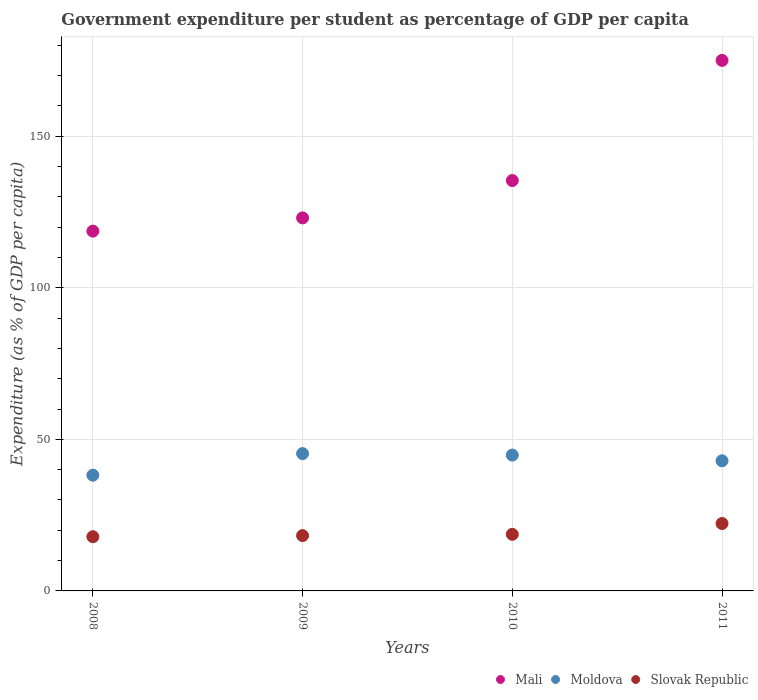What is the percentage of expenditure per student in Moldova in 2008?
Make the answer very short. 38.18. Across all years, what is the maximum percentage of expenditure per student in Moldova?
Your answer should be compact. 45.31. Across all years, what is the minimum percentage of expenditure per student in Mali?
Ensure brevity in your answer.  118.71. In which year was the percentage of expenditure per student in Mali maximum?
Provide a short and direct response. 2011. In which year was the percentage of expenditure per student in Mali minimum?
Your answer should be compact. 2008. What is the total percentage of expenditure per student in Slovak Republic in the graph?
Your answer should be compact. 77.05. What is the difference between the percentage of expenditure per student in Mali in 2008 and that in 2011?
Make the answer very short. -56.33. What is the difference between the percentage of expenditure per student in Slovak Republic in 2010 and the percentage of expenditure per student in Mali in 2008?
Ensure brevity in your answer.  -100.04. What is the average percentage of expenditure per student in Mali per year?
Provide a succinct answer. 138.06. In the year 2008, what is the difference between the percentage of expenditure per student in Slovak Republic and percentage of expenditure per student in Mali?
Make the answer very short. -100.82. In how many years, is the percentage of expenditure per student in Moldova greater than 170 %?
Provide a short and direct response. 0. What is the ratio of the percentage of expenditure per student in Slovak Republic in 2008 to that in 2011?
Provide a succinct answer. 0.8. Is the percentage of expenditure per student in Moldova in 2008 less than that in 2009?
Offer a very short reply. Yes. Is the difference between the percentage of expenditure per student in Slovak Republic in 2009 and 2010 greater than the difference between the percentage of expenditure per student in Mali in 2009 and 2010?
Ensure brevity in your answer.  Yes. What is the difference between the highest and the second highest percentage of expenditure per student in Slovak Republic?
Your answer should be very brief. 3.56. What is the difference between the highest and the lowest percentage of expenditure per student in Mali?
Offer a terse response. 56.33. In how many years, is the percentage of expenditure per student in Slovak Republic greater than the average percentage of expenditure per student in Slovak Republic taken over all years?
Your response must be concise. 1. Does the percentage of expenditure per student in Slovak Republic monotonically increase over the years?
Your answer should be compact. Yes. Is the percentage of expenditure per student in Moldova strictly less than the percentage of expenditure per student in Mali over the years?
Your answer should be very brief. Yes. How many dotlines are there?
Offer a very short reply. 3. What is the difference between two consecutive major ticks on the Y-axis?
Your answer should be compact. 50. Are the values on the major ticks of Y-axis written in scientific E-notation?
Provide a succinct answer. No. Does the graph contain grids?
Provide a short and direct response. Yes. Where does the legend appear in the graph?
Provide a short and direct response. Bottom right. How are the legend labels stacked?
Your response must be concise. Horizontal. What is the title of the graph?
Offer a very short reply. Government expenditure per student as percentage of GDP per capita. What is the label or title of the Y-axis?
Ensure brevity in your answer.  Expenditure (as % of GDP per capita). What is the Expenditure (as % of GDP per capita) of Mali in 2008?
Make the answer very short. 118.71. What is the Expenditure (as % of GDP per capita) of Moldova in 2008?
Provide a short and direct response. 38.18. What is the Expenditure (as % of GDP per capita) in Slovak Republic in 2008?
Keep it short and to the point. 17.89. What is the Expenditure (as % of GDP per capita) in Mali in 2009?
Your answer should be compact. 123.07. What is the Expenditure (as % of GDP per capita) in Moldova in 2009?
Offer a very short reply. 45.31. What is the Expenditure (as % of GDP per capita) of Slovak Republic in 2009?
Provide a succinct answer. 18.25. What is the Expenditure (as % of GDP per capita) of Mali in 2010?
Your answer should be very brief. 135.4. What is the Expenditure (as % of GDP per capita) of Moldova in 2010?
Your response must be concise. 44.82. What is the Expenditure (as % of GDP per capita) in Slovak Republic in 2010?
Offer a terse response. 18.67. What is the Expenditure (as % of GDP per capita) of Mali in 2011?
Keep it short and to the point. 175.04. What is the Expenditure (as % of GDP per capita) in Moldova in 2011?
Your response must be concise. 42.94. What is the Expenditure (as % of GDP per capita) in Slovak Republic in 2011?
Offer a terse response. 22.24. Across all years, what is the maximum Expenditure (as % of GDP per capita) in Mali?
Your response must be concise. 175.04. Across all years, what is the maximum Expenditure (as % of GDP per capita) of Moldova?
Your answer should be very brief. 45.31. Across all years, what is the maximum Expenditure (as % of GDP per capita) in Slovak Republic?
Give a very brief answer. 22.24. Across all years, what is the minimum Expenditure (as % of GDP per capita) in Mali?
Offer a terse response. 118.71. Across all years, what is the minimum Expenditure (as % of GDP per capita) in Moldova?
Your response must be concise. 38.18. Across all years, what is the minimum Expenditure (as % of GDP per capita) of Slovak Republic?
Offer a very short reply. 17.89. What is the total Expenditure (as % of GDP per capita) of Mali in the graph?
Your response must be concise. 552.23. What is the total Expenditure (as % of GDP per capita) of Moldova in the graph?
Provide a succinct answer. 171.25. What is the total Expenditure (as % of GDP per capita) in Slovak Republic in the graph?
Make the answer very short. 77.05. What is the difference between the Expenditure (as % of GDP per capita) in Mali in 2008 and that in 2009?
Your answer should be very brief. -4.36. What is the difference between the Expenditure (as % of GDP per capita) in Moldova in 2008 and that in 2009?
Ensure brevity in your answer.  -7.12. What is the difference between the Expenditure (as % of GDP per capita) of Slovak Republic in 2008 and that in 2009?
Provide a short and direct response. -0.36. What is the difference between the Expenditure (as % of GDP per capita) in Mali in 2008 and that in 2010?
Provide a short and direct response. -16.69. What is the difference between the Expenditure (as % of GDP per capita) in Moldova in 2008 and that in 2010?
Provide a succinct answer. -6.64. What is the difference between the Expenditure (as % of GDP per capita) in Slovak Republic in 2008 and that in 2010?
Your response must be concise. -0.79. What is the difference between the Expenditure (as % of GDP per capita) in Mali in 2008 and that in 2011?
Make the answer very short. -56.33. What is the difference between the Expenditure (as % of GDP per capita) in Moldova in 2008 and that in 2011?
Your response must be concise. -4.75. What is the difference between the Expenditure (as % of GDP per capita) of Slovak Republic in 2008 and that in 2011?
Offer a very short reply. -4.35. What is the difference between the Expenditure (as % of GDP per capita) of Mali in 2009 and that in 2010?
Your answer should be very brief. -12.33. What is the difference between the Expenditure (as % of GDP per capita) in Moldova in 2009 and that in 2010?
Offer a terse response. 0.48. What is the difference between the Expenditure (as % of GDP per capita) of Slovak Republic in 2009 and that in 2010?
Your answer should be compact. -0.42. What is the difference between the Expenditure (as % of GDP per capita) in Mali in 2009 and that in 2011?
Make the answer very short. -51.97. What is the difference between the Expenditure (as % of GDP per capita) of Moldova in 2009 and that in 2011?
Your response must be concise. 2.37. What is the difference between the Expenditure (as % of GDP per capita) of Slovak Republic in 2009 and that in 2011?
Your answer should be very brief. -3.99. What is the difference between the Expenditure (as % of GDP per capita) in Mali in 2010 and that in 2011?
Ensure brevity in your answer.  -39.64. What is the difference between the Expenditure (as % of GDP per capita) of Moldova in 2010 and that in 2011?
Give a very brief answer. 1.89. What is the difference between the Expenditure (as % of GDP per capita) of Slovak Republic in 2010 and that in 2011?
Provide a short and direct response. -3.56. What is the difference between the Expenditure (as % of GDP per capita) in Mali in 2008 and the Expenditure (as % of GDP per capita) in Moldova in 2009?
Ensure brevity in your answer.  73.4. What is the difference between the Expenditure (as % of GDP per capita) of Mali in 2008 and the Expenditure (as % of GDP per capita) of Slovak Republic in 2009?
Offer a very short reply. 100.46. What is the difference between the Expenditure (as % of GDP per capita) in Moldova in 2008 and the Expenditure (as % of GDP per capita) in Slovak Republic in 2009?
Your answer should be compact. 19.93. What is the difference between the Expenditure (as % of GDP per capita) in Mali in 2008 and the Expenditure (as % of GDP per capita) in Moldova in 2010?
Give a very brief answer. 73.89. What is the difference between the Expenditure (as % of GDP per capita) in Mali in 2008 and the Expenditure (as % of GDP per capita) in Slovak Republic in 2010?
Make the answer very short. 100.04. What is the difference between the Expenditure (as % of GDP per capita) in Moldova in 2008 and the Expenditure (as % of GDP per capita) in Slovak Republic in 2010?
Keep it short and to the point. 19.51. What is the difference between the Expenditure (as % of GDP per capita) in Mali in 2008 and the Expenditure (as % of GDP per capita) in Moldova in 2011?
Keep it short and to the point. 75.78. What is the difference between the Expenditure (as % of GDP per capita) in Mali in 2008 and the Expenditure (as % of GDP per capita) in Slovak Republic in 2011?
Offer a very short reply. 96.47. What is the difference between the Expenditure (as % of GDP per capita) in Moldova in 2008 and the Expenditure (as % of GDP per capita) in Slovak Republic in 2011?
Your answer should be very brief. 15.95. What is the difference between the Expenditure (as % of GDP per capita) of Mali in 2009 and the Expenditure (as % of GDP per capita) of Moldova in 2010?
Your answer should be very brief. 78.25. What is the difference between the Expenditure (as % of GDP per capita) of Mali in 2009 and the Expenditure (as % of GDP per capita) of Slovak Republic in 2010?
Make the answer very short. 104.4. What is the difference between the Expenditure (as % of GDP per capita) of Moldova in 2009 and the Expenditure (as % of GDP per capita) of Slovak Republic in 2010?
Give a very brief answer. 26.64. What is the difference between the Expenditure (as % of GDP per capita) of Mali in 2009 and the Expenditure (as % of GDP per capita) of Moldova in 2011?
Provide a short and direct response. 80.14. What is the difference between the Expenditure (as % of GDP per capita) in Mali in 2009 and the Expenditure (as % of GDP per capita) in Slovak Republic in 2011?
Provide a short and direct response. 100.84. What is the difference between the Expenditure (as % of GDP per capita) in Moldova in 2009 and the Expenditure (as % of GDP per capita) in Slovak Republic in 2011?
Your response must be concise. 23.07. What is the difference between the Expenditure (as % of GDP per capita) in Mali in 2010 and the Expenditure (as % of GDP per capita) in Moldova in 2011?
Provide a short and direct response. 92.47. What is the difference between the Expenditure (as % of GDP per capita) of Mali in 2010 and the Expenditure (as % of GDP per capita) of Slovak Republic in 2011?
Provide a succinct answer. 113.17. What is the difference between the Expenditure (as % of GDP per capita) in Moldova in 2010 and the Expenditure (as % of GDP per capita) in Slovak Republic in 2011?
Provide a succinct answer. 22.59. What is the average Expenditure (as % of GDP per capita) in Mali per year?
Give a very brief answer. 138.06. What is the average Expenditure (as % of GDP per capita) in Moldova per year?
Give a very brief answer. 42.81. What is the average Expenditure (as % of GDP per capita) in Slovak Republic per year?
Your answer should be compact. 19.26. In the year 2008, what is the difference between the Expenditure (as % of GDP per capita) in Mali and Expenditure (as % of GDP per capita) in Moldova?
Your answer should be very brief. 80.53. In the year 2008, what is the difference between the Expenditure (as % of GDP per capita) of Mali and Expenditure (as % of GDP per capita) of Slovak Republic?
Your response must be concise. 100.82. In the year 2008, what is the difference between the Expenditure (as % of GDP per capita) in Moldova and Expenditure (as % of GDP per capita) in Slovak Republic?
Give a very brief answer. 20.3. In the year 2009, what is the difference between the Expenditure (as % of GDP per capita) of Mali and Expenditure (as % of GDP per capita) of Moldova?
Provide a short and direct response. 77.76. In the year 2009, what is the difference between the Expenditure (as % of GDP per capita) of Mali and Expenditure (as % of GDP per capita) of Slovak Republic?
Your answer should be compact. 104.82. In the year 2009, what is the difference between the Expenditure (as % of GDP per capita) in Moldova and Expenditure (as % of GDP per capita) in Slovak Republic?
Offer a very short reply. 27.06. In the year 2010, what is the difference between the Expenditure (as % of GDP per capita) of Mali and Expenditure (as % of GDP per capita) of Moldova?
Provide a succinct answer. 90.58. In the year 2010, what is the difference between the Expenditure (as % of GDP per capita) of Mali and Expenditure (as % of GDP per capita) of Slovak Republic?
Make the answer very short. 116.73. In the year 2010, what is the difference between the Expenditure (as % of GDP per capita) of Moldova and Expenditure (as % of GDP per capita) of Slovak Republic?
Ensure brevity in your answer.  26.15. In the year 2011, what is the difference between the Expenditure (as % of GDP per capita) of Mali and Expenditure (as % of GDP per capita) of Moldova?
Make the answer very short. 132.11. In the year 2011, what is the difference between the Expenditure (as % of GDP per capita) in Mali and Expenditure (as % of GDP per capita) in Slovak Republic?
Give a very brief answer. 152.81. In the year 2011, what is the difference between the Expenditure (as % of GDP per capita) in Moldova and Expenditure (as % of GDP per capita) in Slovak Republic?
Offer a very short reply. 20.7. What is the ratio of the Expenditure (as % of GDP per capita) of Mali in 2008 to that in 2009?
Your answer should be compact. 0.96. What is the ratio of the Expenditure (as % of GDP per capita) in Moldova in 2008 to that in 2009?
Offer a very short reply. 0.84. What is the ratio of the Expenditure (as % of GDP per capita) in Mali in 2008 to that in 2010?
Your response must be concise. 0.88. What is the ratio of the Expenditure (as % of GDP per capita) of Moldova in 2008 to that in 2010?
Give a very brief answer. 0.85. What is the ratio of the Expenditure (as % of GDP per capita) in Slovak Republic in 2008 to that in 2010?
Your answer should be very brief. 0.96. What is the ratio of the Expenditure (as % of GDP per capita) of Mali in 2008 to that in 2011?
Offer a very short reply. 0.68. What is the ratio of the Expenditure (as % of GDP per capita) in Moldova in 2008 to that in 2011?
Ensure brevity in your answer.  0.89. What is the ratio of the Expenditure (as % of GDP per capita) of Slovak Republic in 2008 to that in 2011?
Provide a succinct answer. 0.8. What is the ratio of the Expenditure (as % of GDP per capita) of Mali in 2009 to that in 2010?
Your answer should be very brief. 0.91. What is the ratio of the Expenditure (as % of GDP per capita) of Moldova in 2009 to that in 2010?
Ensure brevity in your answer.  1.01. What is the ratio of the Expenditure (as % of GDP per capita) of Slovak Republic in 2009 to that in 2010?
Ensure brevity in your answer.  0.98. What is the ratio of the Expenditure (as % of GDP per capita) of Mali in 2009 to that in 2011?
Provide a succinct answer. 0.7. What is the ratio of the Expenditure (as % of GDP per capita) in Moldova in 2009 to that in 2011?
Provide a succinct answer. 1.06. What is the ratio of the Expenditure (as % of GDP per capita) of Slovak Republic in 2009 to that in 2011?
Your answer should be very brief. 0.82. What is the ratio of the Expenditure (as % of GDP per capita) of Mali in 2010 to that in 2011?
Your answer should be compact. 0.77. What is the ratio of the Expenditure (as % of GDP per capita) of Moldova in 2010 to that in 2011?
Ensure brevity in your answer.  1.04. What is the ratio of the Expenditure (as % of GDP per capita) of Slovak Republic in 2010 to that in 2011?
Your answer should be very brief. 0.84. What is the difference between the highest and the second highest Expenditure (as % of GDP per capita) in Mali?
Keep it short and to the point. 39.64. What is the difference between the highest and the second highest Expenditure (as % of GDP per capita) of Moldova?
Give a very brief answer. 0.48. What is the difference between the highest and the second highest Expenditure (as % of GDP per capita) of Slovak Republic?
Provide a succinct answer. 3.56. What is the difference between the highest and the lowest Expenditure (as % of GDP per capita) of Mali?
Ensure brevity in your answer.  56.33. What is the difference between the highest and the lowest Expenditure (as % of GDP per capita) in Moldova?
Provide a succinct answer. 7.12. What is the difference between the highest and the lowest Expenditure (as % of GDP per capita) of Slovak Republic?
Your answer should be very brief. 4.35. 